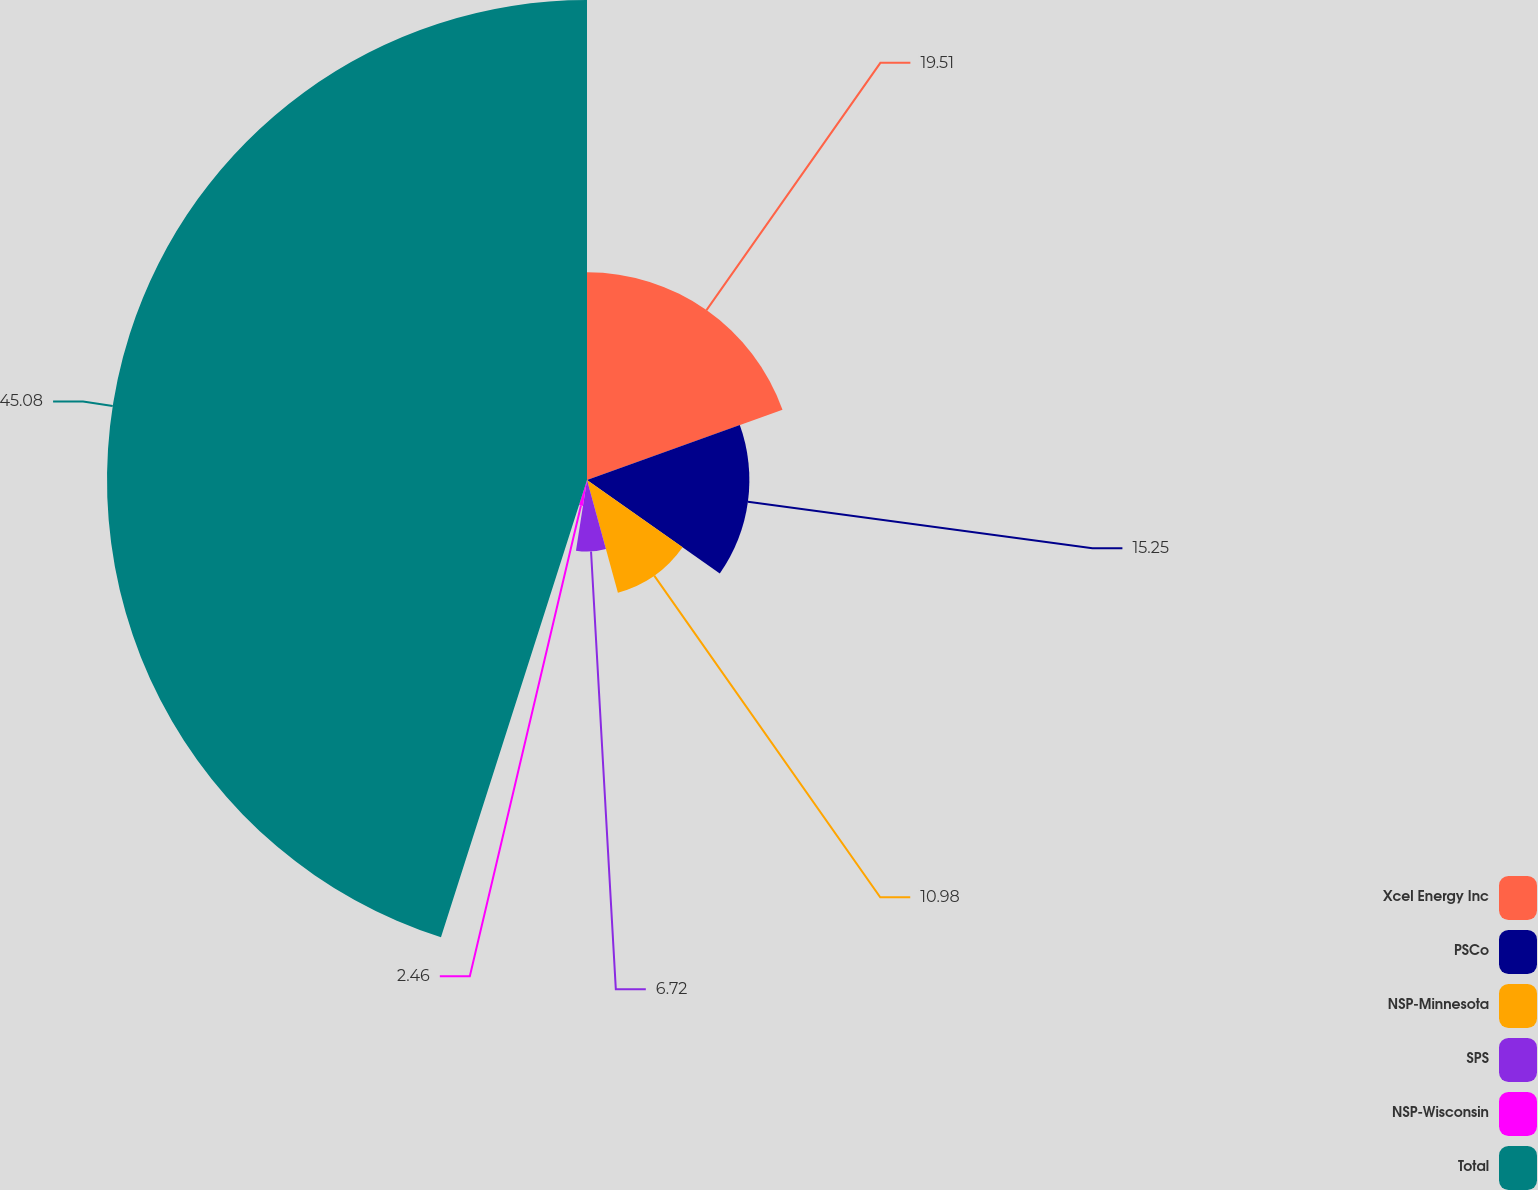Convert chart to OTSL. <chart><loc_0><loc_0><loc_500><loc_500><pie_chart><fcel>Xcel Energy Inc<fcel>PSCo<fcel>NSP-Minnesota<fcel>SPS<fcel>NSP-Wisconsin<fcel>Total<nl><fcel>19.51%<fcel>15.25%<fcel>10.98%<fcel>6.72%<fcel>2.46%<fcel>45.08%<nl></chart> 